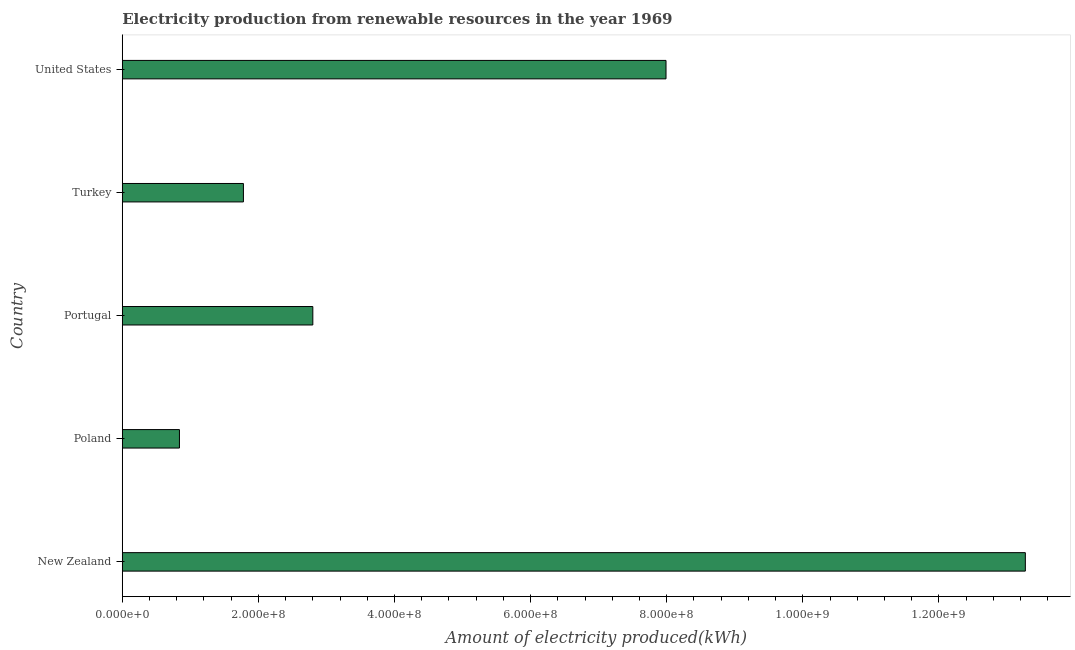Does the graph contain any zero values?
Offer a terse response. No. Does the graph contain grids?
Keep it short and to the point. No. What is the title of the graph?
Keep it short and to the point. Electricity production from renewable resources in the year 1969. What is the label or title of the X-axis?
Provide a short and direct response. Amount of electricity produced(kWh). What is the amount of electricity produced in United States?
Give a very brief answer. 7.99e+08. Across all countries, what is the maximum amount of electricity produced?
Your answer should be very brief. 1.33e+09. Across all countries, what is the minimum amount of electricity produced?
Provide a short and direct response. 8.40e+07. In which country was the amount of electricity produced maximum?
Keep it short and to the point. New Zealand. In which country was the amount of electricity produced minimum?
Make the answer very short. Poland. What is the sum of the amount of electricity produced?
Your answer should be very brief. 2.67e+09. What is the difference between the amount of electricity produced in New Zealand and United States?
Keep it short and to the point. 5.28e+08. What is the average amount of electricity produced per country?
Give a very brief answer. 5.34e+08. What is the median amount of electricity produced?
Your response must be concise. 2.80e+08. In how many countries, is the amount of electricity produced greater than 1080000000 kWh?
Offer a terse response. 1. What is the difference between the highest and the second highest amount of electricity produced?
Offer a terse response. 5.28e+08. What is the difference between the highest and the lowest amount of electricity produced?
Keep it short and to the point. 1.24e+09. In how many countries, is the amount of electricity produced greater than the average amount of electricity produced taken over all countries?
Give a very brief answer. 2. How many bars are there?
Keep it short and to the point. 5. What is the difference between two consecutive major ticks on the X-axis?
Your response must be concise. 2.00e+08. What is the Amount of electricity produced(kWh) of New Zealand?
Your answer should be very brief. 1.33e+09. What is the Amount of electricity produced(kWh) in Poland?
Offer a very short reply. 8.40e+07. What is the Amount of electricity produced(kWh) in Portugal?
Give a very brief answer. 2.80e+08. What is the Amount of electricity produced(kWh) of Turkey?
Your answer should be very brief. 1.78e+08. What is the Amount of electricity produced(kWh) of United States?
Ensure brevity in your answer.  7.99e+08. What is the difference between the Amount of electricity produced(kWh) in New Zealand and Poland?
Ensure brevity in your answer.  1.24e+09. What is the difference between the Amount of electricity produced(kWh) in New Zealand and Portugal?
Your response must be concise. 1.05e+09. What is the difference between the Amount of electricity produced(kWh) in New Zealand and Turkey?
Make the answer very short. 1.15e+09. What is the difference between the Amount of electricity produced(kWh) in New Zealand and United States?
Provide a short and direct response. 5.28e+08. What is the difference between the Amount of electricity produced(kWh) in Poland and Portugal?
Your answer should be very brief. -1.96e+08. What is the difference between the Amount of electricity produced(kWh) in Poland and Turkey?
Your answer should be very brief. -9.40e+07. What is the difference between the Amount of electricity produced(kWh) in Poland and United States?
Your response must be concise. -7.15e+08. What is the difference between the Amount of electricity produced(kWh) in Portugal and Turkey?
Your response must be concise. 1.02e+08. What is the difference between the Amount of electricity produced(kWh) in Portugal and United States?
Ensure brevity in your answer.  -5.19e+08. What is the difference between the Amount of electricity produced(kWh) in Turkey and United States?
Offer a very short reply. -6.21e+08. What is the ratio of the Amount of electricity produced(kWh) in New Zealand to that in Poland?
Give a very brief answer. 15.8. What is the ratio of the Amount of electricity produced(kWh) in New Zealand to that in Portugal?
Provide a short and direct response. 4.74. What is the ratio of the Amount of electricity produced(kWh) in New Zealand to that in Turkey?
Offer a very short reply. 7.46. What is the ratio of the Amount of electricity produced(kWh) in New Zealand to that in United States?
Make the answer very short. 1.66. What is the ratio of the Amount of electricity produced(kWh) in Poland to that in Portugal?
Your answer should be compact. 0.3. What is the ratio of the Amount of electricity produced(kWh) in Poland to that in Turkey?
Give a very brief answer. 0.47. What is the ratio of the Amount of electricity produced(kWh) in Poland to that in United States?
Your response must be concise. 0.1. What is the ratio of the Amount of electricity produced(kWh) in Portugal to that in Turkey?
Ensure brevity in your answer.  1.57. What is the ratio of the Amount of electricity produced(kWh) in Turkey to that in United States?
Ensure brevity in your answer.  0.22. 